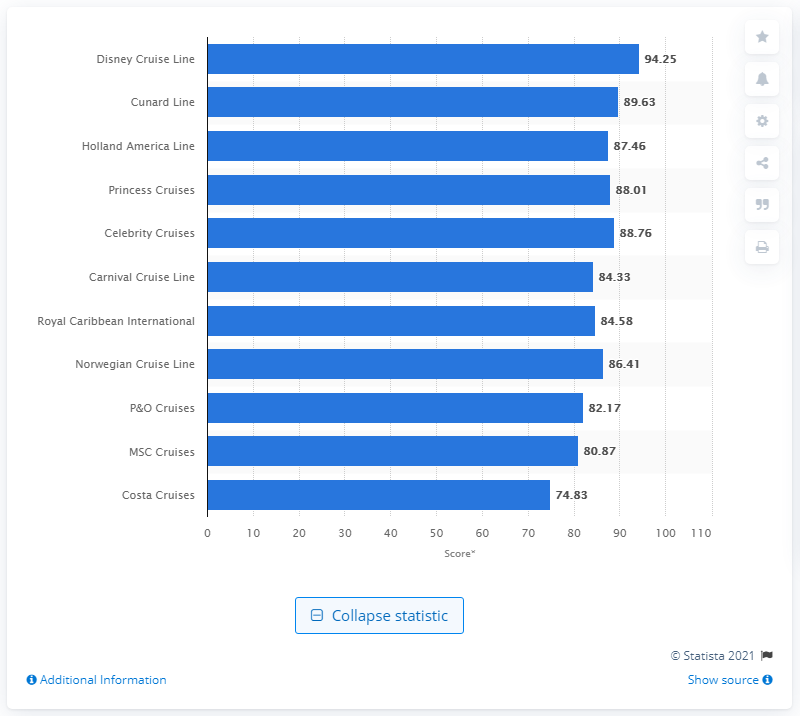Give some essential details in this illustration. In the Condé Nast Traveler's 2021 Readers' Choice Awards, Disney Cruise Line received a score of 94.25, which reflects the high satisfaction of its customers. According to the readers of Condé Nast Traveler, the best large-ship cruise line is Disney Cruise Line. 